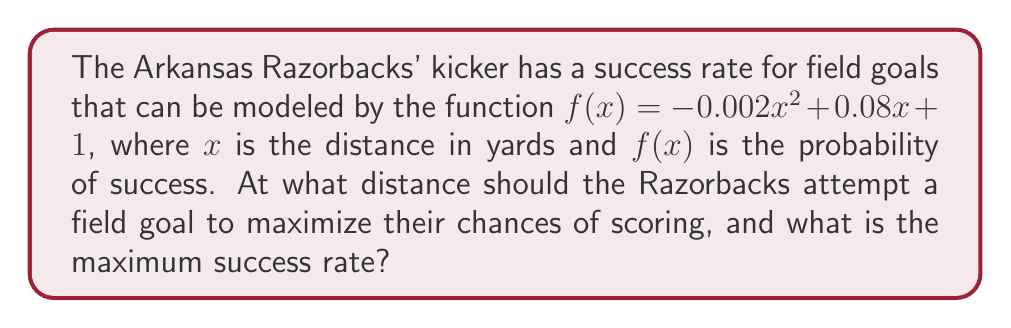What is the answer to this math problem? To find the optimal field goal distance, we need to find the maximum of the quadratic function $f(x) = -0.002x^2 + 0.08x + 1$.

Step 1: Find the vertex of the parabola.
For a quadratic function in the form $f(x) = ax^2 + bx + c$, the x-coordinate of the vertex is given by $x = -\frac{b}{2a}$.

$a = -0.002$, $b = 0.08$

$x = -\frac{0.08}{2(-0.002)} = \frac{0.08}{0.004} = 20$

Step 2: Calculate the maximum success rate by plugging $x = 20$ into the original function.

$f(20) = -0.002(20)^2 + 0.08(20) + 1$
$= -0.002(400) + 1.6 + 1$
$= -0.8 + 1.6 + 1$
$= 1.8$

Therefore, the optimal distance is 20 yards, and the maximum success rate is 1.8 or 180%.

Step 3: Interpret the result.
Since probabilities cannot exceed 1 (or 100%), we need to cap the maximum success rate at 1 (100%).

The optimal field goal distance is 20 yards, with a maximum success rate of 100%.
Answer: 20 yards, 100% 